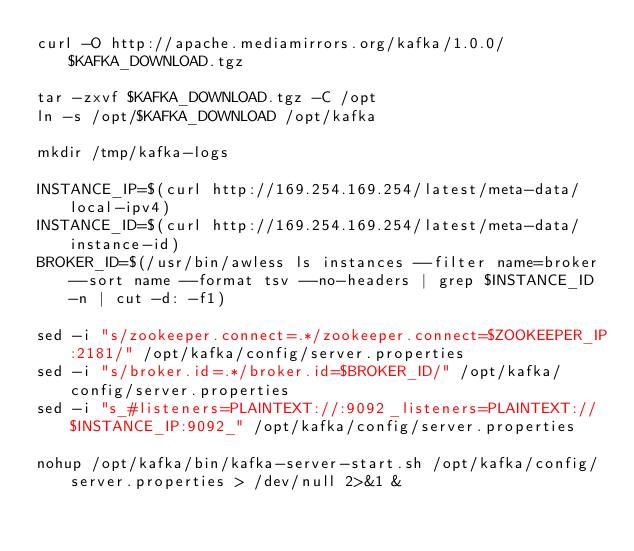Convert code to text. <code><loc_0><loc_0><loc_500><loc_500><_Bash_>curl -O http://apache.mediamirrors.org/kafka/1.0.0/$KAFKA_DOWNLOAD.tgz

tar -zxvf $KAFKA_DOWNLOAD.tgz -C /opt
ln -s /opt/$KAFKA_DOWNLOAD /opt/kafka

mkdir /tmp/kafka-logs

INSTANCE_IP=$(curl http://169.254.169.254/latest/meta-data/local-ipv4)
INSTANCE_ID=$(curl http://169.254.169.254/latest/meta-data/instance-id)
BROKER_ID=$(/usr/bin/awless ls instances --filter name=broker --sort name --format tsv --no-headers | grep $INSTANCE_ID -n | cut -d: -f1)

sed -i "s/zookeeper.connect=.*/zookeeper.connect=$ZOOKEEPER_IP:2181/" /opt/kafka/config/server.properties
sed -i "s/broker.id=.*/broker.id=$BROKER_ID/" /opt/kafka/config/server.properties
sed -i "s_#listeners=PLAINTEXT://:9092_listeners=PLAINTEXT://$INSTANCE_IP:9092_" /opt/kafka/config/server.properties

nohup /opt/kafka/bin/kafka-server-start.sh /opt/kafka/config/server.properties > /dev/null 2>&1 &</code> 